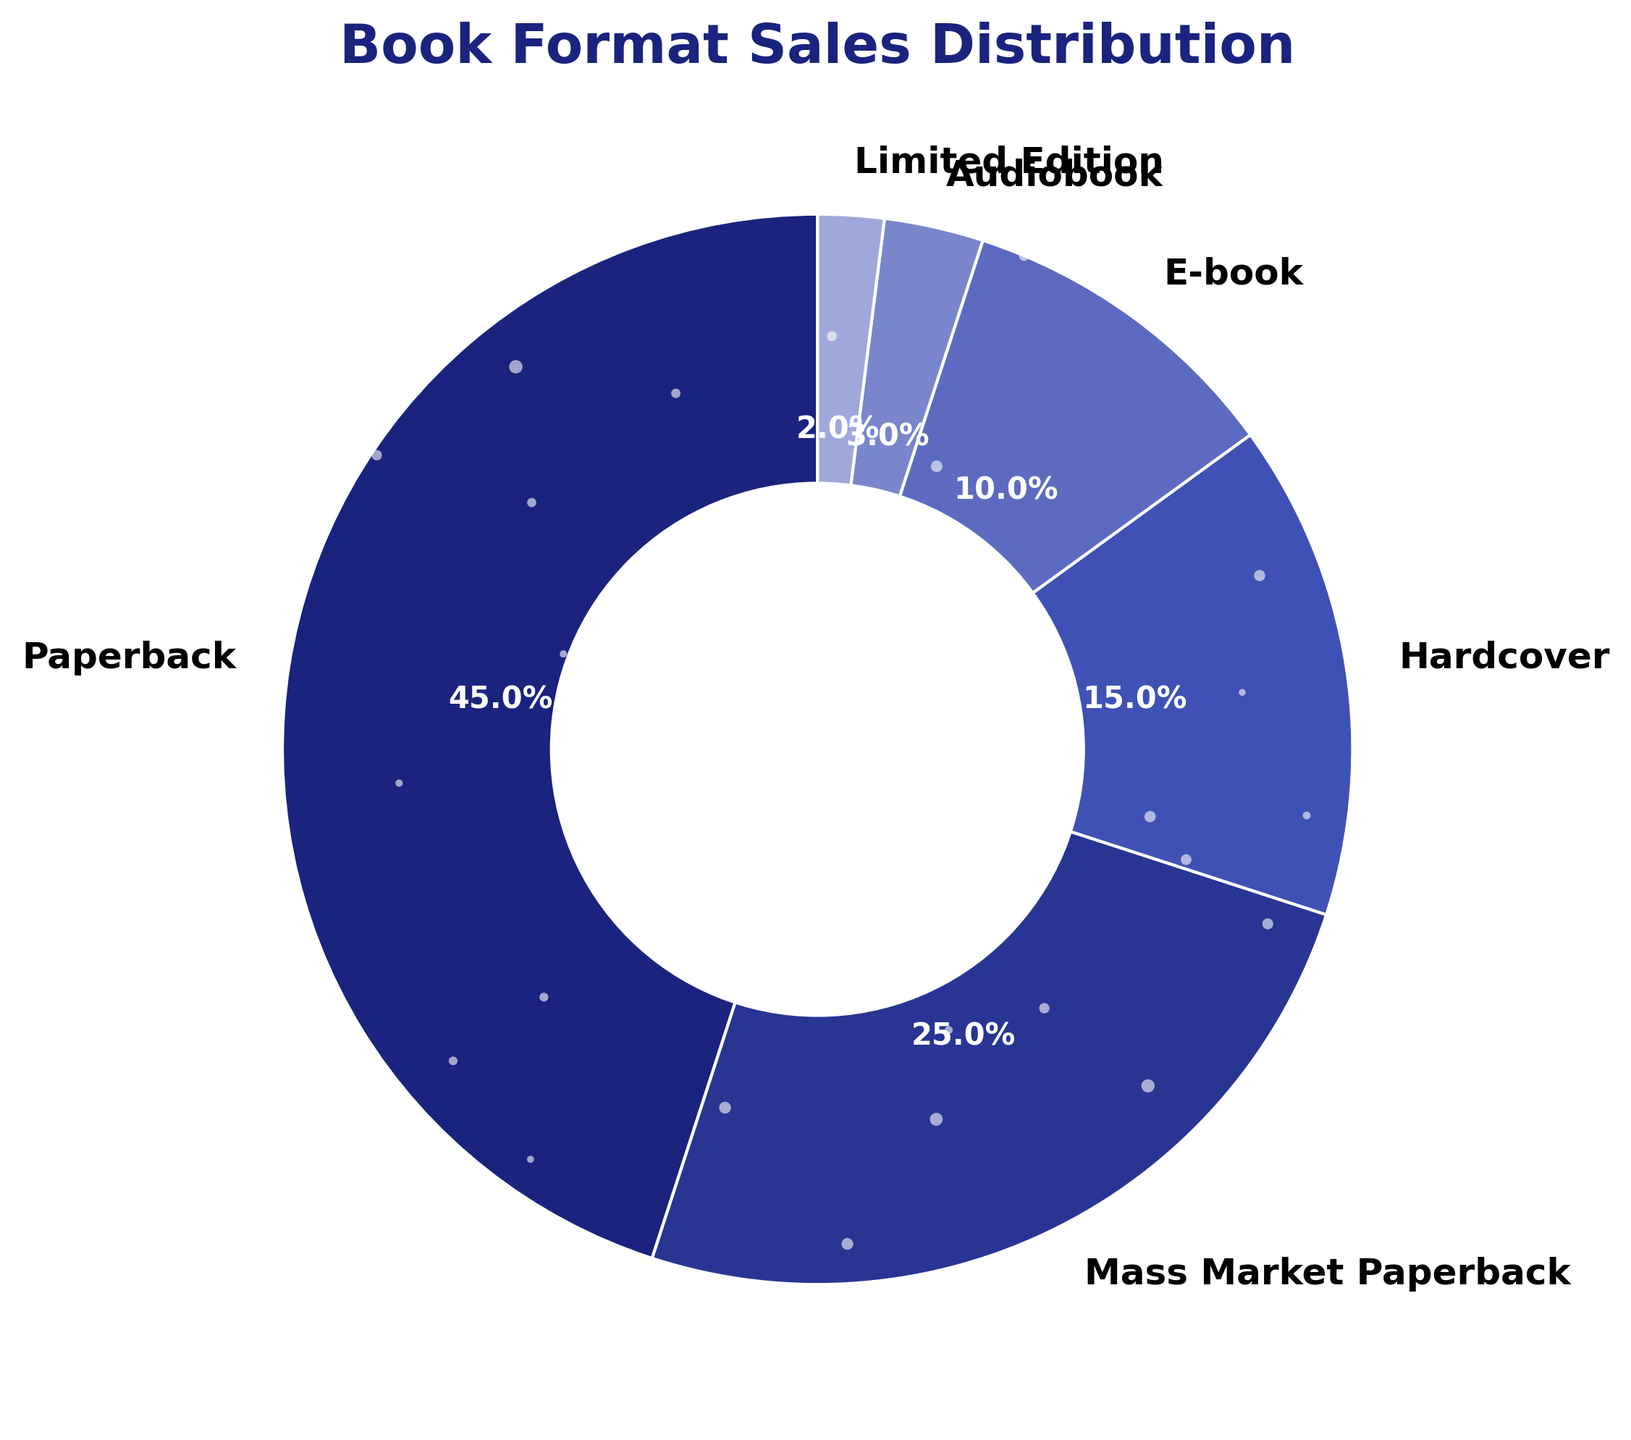What percentage of sales do paperback and mass market paperback formats together represent? Add the percentage of paperback (45%) and mass market paperback (25%). 45% + 25% = 70%
Answer: 70% Which book format has the lowest sales percentage? Identify the format with the smallest slice in the pie chart. The limited edition format has the smallest slice representing 2% of sales.
Answer: Limited Edition How much higher is the percentage of paperback sales compared to hardcover sales? Subtract the percentage of hardcover (15%) from the percentage of paperback (45%). 45% - 15% = 30%
Answer: 30% What is the total percentage of sales for e-book and audiobook formats combined? Add the percentage of e-book (10%) and audiobook (3%). 10% + 3% = 13%
Answer: 13% Which two formats together constitute exactly half of the total sales? Identify two formats that add up to 50%. Paperback (45%) and limited edition (2%) together make 47%, which is not 50%. However, paperback (45%) and audiobook (3%) make 48%, which is closer but not accurate. Mass market paperback (25%) and hardcover (15%) together do not make 50%. Combining mass market paperback (25%) and e-book (10%) makes 35%. Thus, the exact half of sales cannot be identified with two formats.
Answer: Not Applicable (NA) Are there more sales in e-book format or audiobook format? Compare the percentages for e-book (10%) and audiobook (3%). E-book (10%) is greater than audiobook (3%).
Answer: E-book Which format, hardcover or limited edition, has a higher sales percentage? Compare the percentages for hardcover (15%) and limited edition (2%). Hardcover (15%) is higher than limited edition (2%).
Answer: Hardcover What fraction of total sales does the mass market paperback format represent? Convert the percentage of mass market paperback (25%) into a fraction. 25% is equivalent to 25/100 or 1/4.
Answer: 1/4 What is the difference in sales percentage between the most popular and least popular formats? Identify the most and least popular formats. The most popular is paperback (45%), and the least popular is limited edition (2%). Subtract the least popular percentage from the most popular. 45% - 2% = 43%
Answer: 43% Which formats together make up more than 80% of total sales? Calculate step-by-step to find the combination. Paperback (45%) and mass market paperback (25%) together make 70%. Adding hardcover (15%) to this makes 85%. Since 70% + 15% = 85%, these three formats together make up more than 80%.
Answer: Paperback, Mass Market Paperback, Hardcover 